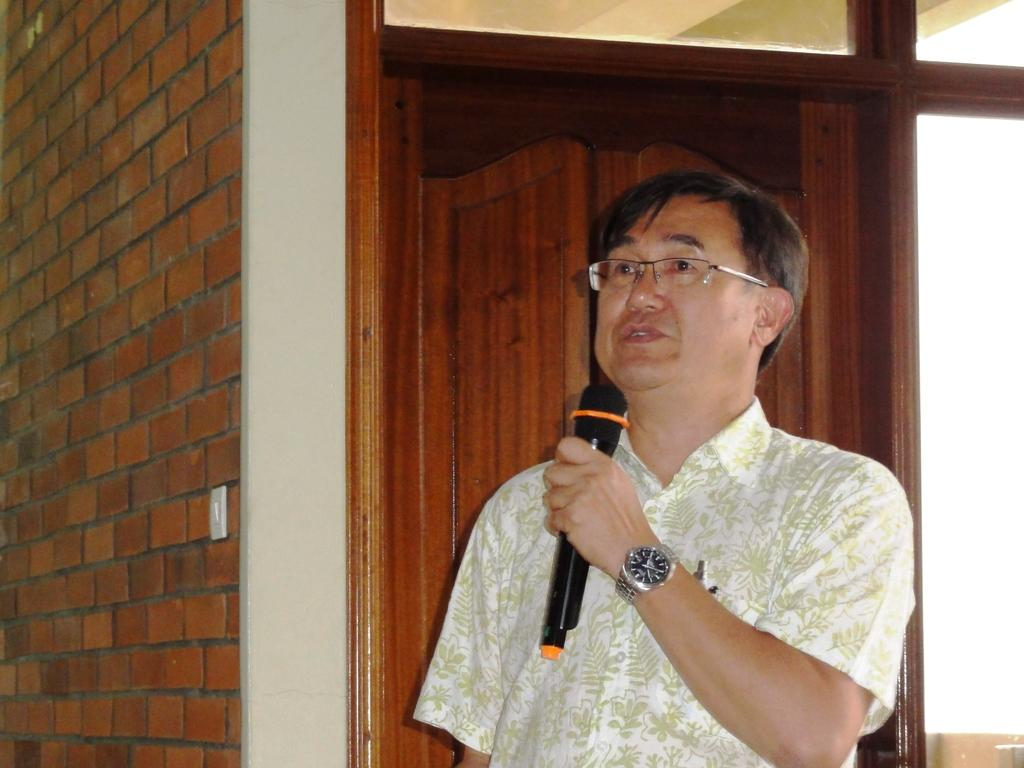What is the person in the image doing? The person is standing in the image and holding a microphone. What can be seen in the background of the image? There is a wall and a door in the background of the image. What other object is present in the image? There is a switchboard in the image. What type of low-frequency sound can be heard in the image? There is no indication of any sound in the image, so it cannot be determined if any low-frequency sound is present. 